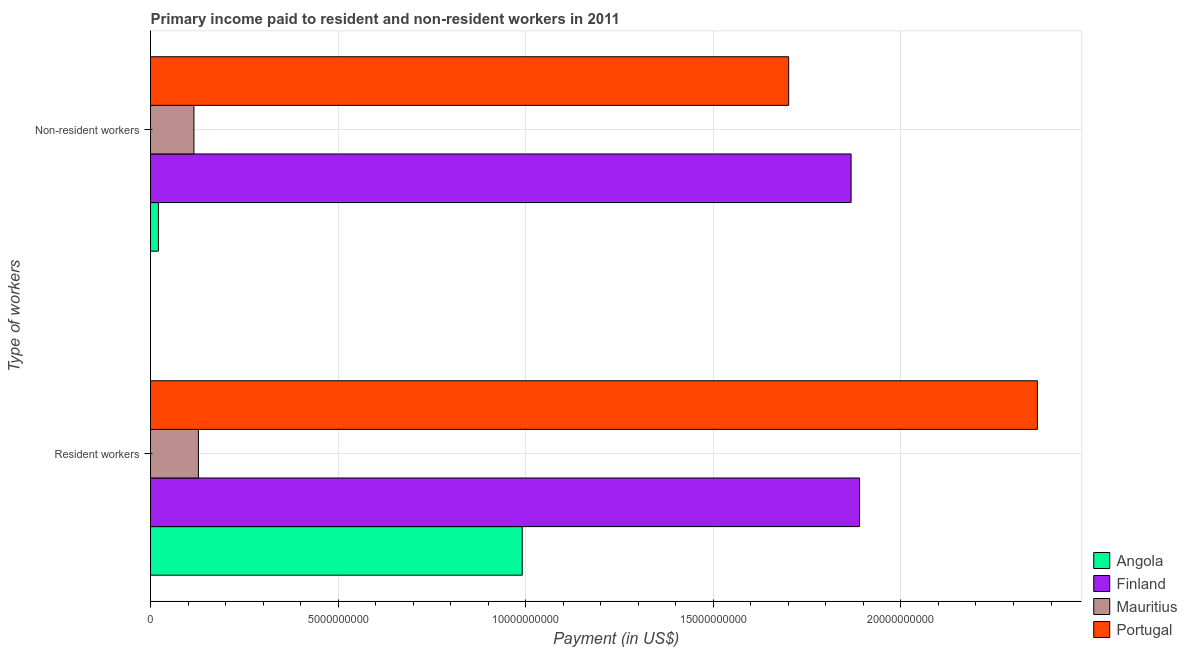How many groups of bars are there?
Your answer should be very brief. 2. Are the number of bars per tick equal to the number of legend labels?
Offer a very short reply. Yes. How many bars are there on the 2nd tick from the bottom?
Your answer should be very brief. 4. What is the label of the 1st group of bars from the top?
Your answer should be compact. Non-resident workers. What is the payment made to non-resident workers in Portugal?
Give a very brief answer. 1.70e+1. Across all countries, what is the maximum payment made to resident workers?
Provide a short and direct response. 2.36e+1. Across all countries, what is the minimum payment made to non-resident workers?
Provide a short and direct response. 2.10e+08. In which country was the payment made to resident workers minimum?
Ensure brevity in your answer.  Mauritius. What is the total payment made to resident workers in the graph?
Provide a short and direct response. 5.37e+1. What is the difference between the payment made to resident workers in Mauritius and that in Angola?
Offer a very short reply. -8.63e+09. What is the difference between the payment made to non-resident workers in Finland and the payment made to resident workers in Mauritius?
Make the answer very short. 1.74e+1. What is the average payment made to non-resident workers per country?
Make the answer very short. 9.26e+09. What is the difference between the payment made to resident workers and payment made to non-resident workers in Portugal?
Offer a terse response. 6.63e+09. What is the ratio of the payment made to non-resident workers in Mauritius to that in Angola?
Provide a succinct answer. 5.51. What does the 4th bar from the top in Resident workers represents?
Your answer should be compact. Angola. What does the 3rd bar from the bottom in Resident workers represents?
Keep it short and to the point. Mauritius. Are the values on the major ticks of X-axis written in scientific E-notation?
Offer a terse response. No. Does the graph contain any zero values?
Your answer should be very brief. No. How are the legend labels stacked?
Your answer should be very brief. Vertical. What is the title of the graph?
Your answer should be very brief. Primary income paid to resident and non-resident workers in 2011. What is the label or title of the X-axis?
Offer a very short reply. Payment (in US$). What is the label or title of the Y-axis?
Keep it short and to the point. Type of workers. What is the Payment (in US$) of Angola in Resident workers?
Offer a very short reply. 9.91e+09. What is the Payment (in US$) of Finland in Resident workers?
Give a very brief answer. 1.89e+1. What is the Payment (in US$) of Mauritius in Resident workers?
Your response must be concise. 1.28e+09. What is the Payment (in US$) of Portugal in Resident workers?
Provide a short and direct response. 2.36e+1. What is the Payment (in US$) in Angola in Non-resident workers?
Make the answer very short. 2.10e+08. What is the Payment (in US$) in Finland in Non-resident workers?
Make the answer very short. 1.87e+1. What is the Payment (in US$) of Mauritius in Non-resident workers?
Keep it short and to the point. 1.16e+09. What is the Payment (in US$) in Portugal in Non-resident workers?
Offer a terse response. 1.70e+1. Across all Type of workers, what is the maximum Payment (in US$) in Angola?
Give a very brief answer. 9.91e+09. Across all Type of workers, what is the maximum Payment (in US$) in Finland?
Ensure brevity in your answer.  1.89e+1. Across all Type of workers, what is the maximum Payment (in US$) in Mauritius?
Make the answer very short. 1.28e+09. Across all Type of workers, what is the maximum Payment (in US$) of Portugal?
Make the answer very short. 2.36e+1. Across all Type of workers, what is the minimum Payment (in US$) of Angola?
Give a very brief answer. 2.10e+08. Across all Type of workers, what is the minimum Payment (in US$) of Finland?
Your answer should be compact. 1.87e+1. Across all Type of workers, what is the minimum Payment (in US$) in Mauritius?
Give a very brief answer. 1.16e+09. Across all Type of workers, what is the minimum Payment (in US$) in Portugal?
Your answer should be compact. 1.70e+1. What is the total Payment (in US$) of Angola in the graph?
Your answer should be compact. 1.01e+1. What is the total Payment (in US$) in Finland in the graph?
Your response must be concise. 3.76e+1. What is the total Payment (in US$) in Mauritius in the graph?
Keep it short and to the point. 2.43e+09. What is the total Payment (in US$) in Portugal in the graph?
Your answer should be very brief. 4.06e+1. What is the difference between the Payment (in US$) of Angola in Resident workers and that in Non-resident workers?
Provide a succinct answer. 9.70e+09. What is the difference between the Payment (in US$) in Finland in Resident workers and that in Non-resident workers?
Make the answer very short. 2.26e+08. What is the difference between the Payment (in US$) of Mauritius in Resident workers and that in Non-resident workers?
Give a very brief answer. 1.19e+08. What is the difference between the Payment (in US$) in Portugal in Resident workers and that in Non-resident workers?
Keep it short and to the point. 6.63e+09. What is the difference between the Payment (in US$) in Angola in Resident workers and the Payment (in US$) in Finland in Non-resident workers?
Make the answer very short. -8.76e+09. What is the difference between the Payment (in US$) of Angola in Resident workers and the Payment (in US$) of Mauritius in Non-resident workers?
Provide a short and direct response. 8.75e+09. What is the difference between the Payment (in US$) of Angola in Resident workers and the Payment (in US$) of Portugal in Non-resident workers?
Offer a very short reply. -7.10e+09. What is the difference between the Payment (in US$) of Finland in Resident workers and the Payment (in US$) of Mauritius in Non-resident workers?
Offer a terse response. 1.77e+1. What is the difference between the Payment (in US$) of Finland in Resident workers and the Payment (in US$) of Portugal in Non-resident workers?
Your answer should be very brief. 1.89e+09. What is the difference between the Payment (in US$) of Mauritius in Resident workers and the Payment (in US$) of Portugal in Non-resident workers?
Offer a terse response. -1.57e+1. What is the average Payment (in US$) of Angola per Type of workers?
Your response must be concise. 5.06e+09. What is the average Payment (in US$) of Finland per Type of workers?
Give a very brief answer. 1.88e+1. What is the average Payment (in US$) in Mauritius per Type of workers?
Keep it short and to the point. 1.22e+09. What is the average Payment (in US$) of Portugal per Type of workers?
Your response must be concise. 2.03e+1. What is the difference between the Payment (in US$) of Angola and Payment (in US$) of Finland in Resident workers?
Offer a terse response. -8.99e+09. What is the difference between the Payment (in US$) of Angola and Payment (in US$) of Mauritius in Resident workers?
Provide a succinct answer. 8.63e+09. What is the difference between the Payment (in US$) of Angola and Payment (in US$) of Portugal in Resident workers?
Offer a terse response. -1.37e+1. What is the difference between the Payment (in US$) in Finland and Payment (in US$) in Mauritius in Resident workers?
Provide a short and direct response. 1.76e+1. What is the difference between the Payment (in US$) of Finland and Payment (in US$) of Portugal in Resident workers?
Provide a short and direct response. -4.74e+09. What is the difference between the Payment (in US$) in Mauritius and Payment (in US$) in Portugal in Resident workers?
Keep it short and to the point. -2.24e+1. What is the difference between the Payment (in US$) of Angola and Payment (in US$) of Finland in Non-resident workers?
Provide a succinct answer. -1.85e+1. What is the difference between the Payment (in US$) of Angola and Payment (in US$) of Mauritius in Non-resident workers?
Your answer should be very brief. -9.47e+08. What is the difference between the Payment (in US$) in Angola and Payment (in US$) in Portugal in Non-resident workers?
Provide a short and direct response. -1.68e+1. What is the difference between the Payment (in US$) of Finland and Payment (in US$) of Mauritius in Non-resident workers?
Your answer should be compact. 1.75e+1. What is the difference between the Payment (in US$) of Finland and Payment (in US$) of Portugal in Non-resident workers?
Provide a short and direct response. 1.66e+09. What is the difference between the Payment (in US$) of Mauritius and Payment (in US$) of Portugal in Non-resident workers?
Keep it short and to the point. -1.59e+1. What is the ratio of the Payment (in US$) in Angola in Resident workers to that in Non-resident workers?
Offer a terse response. 47.22. What is the ratio of the Payment (in US$) in Finland in Resident workers to that in Non-resident workers?
Ensure brevity in your answer.  1.01. What is the ratio of the Payment (in US$) of Mauritius in Resident workers to that in Non-resident workers?
Provide a succinct answer. 1.1. What is the ratio of the Payment (in US$) in Portugal in Resident workers to that in Non-resident workers?
Give a very brief answer. 1.39. What is the difference between the highest and the second highest Payment (in US$) in Angola?
Your answer should be compact. 9.70e+09. What is the difference between the highest and the second highest Payment (in US$) in Finland?
Make the answer very short. 2.26e+08. What is the difference between the highest and the second highest Payment (in US$) in Mauritius?
Your answer should be very brief. 1.19e+08. What is the difference between the highest and the second highest Payment (in US$) in Portugal?
Make the answer very short. 6.63e+09. What is the difference between the highest and the lowest Payment (in US$) in Angola?
Provide a short and direct response. 9.70e+09. What is the difference between the highest and the lowest Payment (in US$) in Finland?
Your response must be concise. 2.26e+08. What is the difference between the highest and the lowest Payment (in US$) of Mauritius?
Ensure brevity in your answer.  1.19e+08. What is the difference between the highest and the lowest Payment (in US$) in Portugal?
Give a very brief answer. 6.63e+09. 